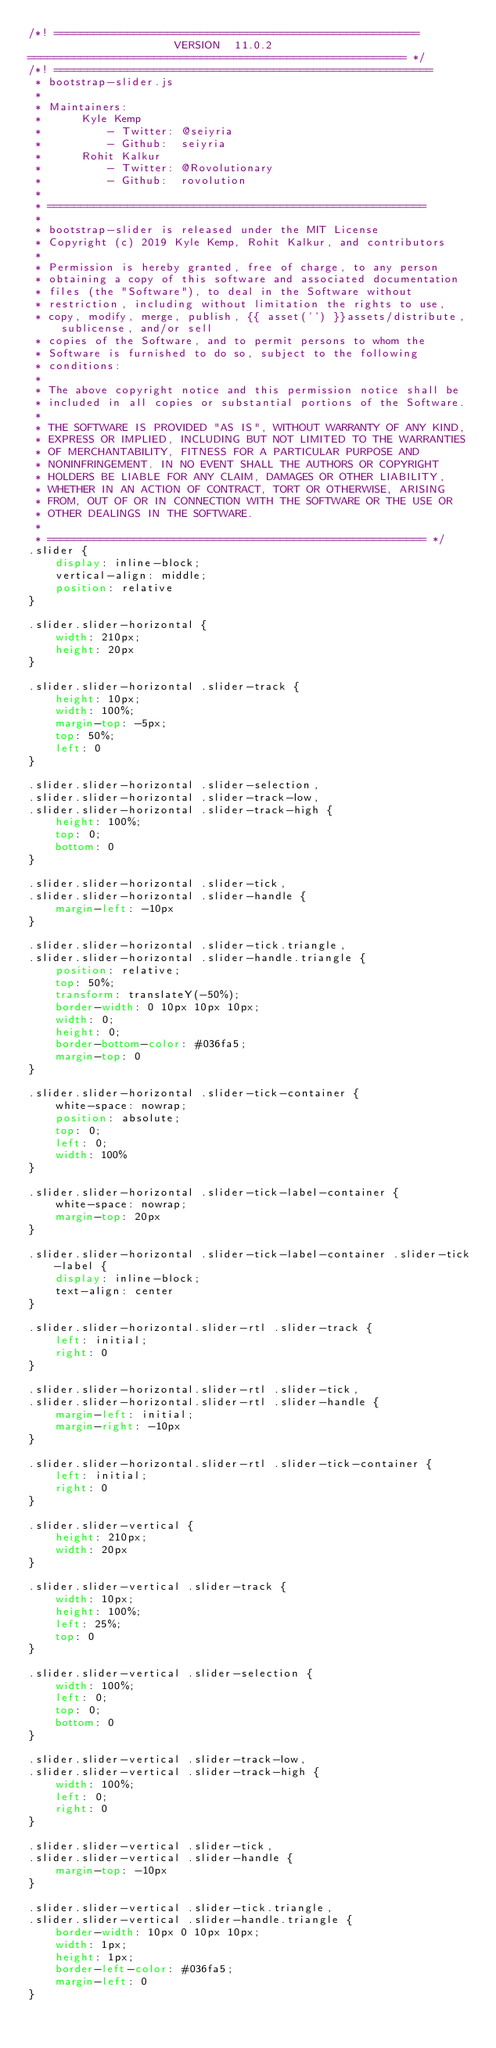<code> <loc_0><loc_0><loc_500><loc_500><_CSS_>/*! =======================================================
                      VERSION  11.0.2              
========================================================= */
/*! =========================================================
 * bootstrap-slider.js
 *
 * Maintainers:
 *		Kyle Kemp
 *			- Twitter: @seiyria
 *			- Github:  seiyria
 *		Rohit Kalkur
 *			- Twitter: @Rovolutionary
 *			- Github:  rovolution
 *
 * =========================================================
 *
 * bootstrap-slider is released under the MIT License
 * Copyright (c) 2019 Kyle Kemp, Rohit Kalkur, and contributors
 * 
 * Permission is hereby granted, free of charge, to any person
 * obtaining a copy of this software and associated documentation
 * files (the "Software"), to deal in the Software without
 * restriction, including without limitation the rights to use,
 * copy, modify, merge, publish, {{ asset('') }}assets/distribute, sublicense, and/or sell
 * copies of the Software, and to permit persons to whom the
 * Software is furnished to do so, subject to the following
 * conditions:
 * 
 * The above copyright notice and this permission notice shall be
 * included in all copies or substantial portions of the Software.
 * 
 * THE SOFTWARE IS PROVIDED "AS IS", WITHOUT WARRANTY OF ANY KIND,
 * EXPRESS OR IMPLIED, INCLUDING BUT NOT LIMITED TO THE WARRANTIES
 * OF MERCHANTABILITY, FITNESS FOR A PARTICULAR PURPOSE AND
 * NONINFRINGEMENT. IN NO EVENT SHALL THE AUTHORS OR COPYRIGHT
 * HOLDERS BE LIABLE FOR ANY CLAIM, DAMAGES OR OTHER LIABILITY,
 * WHETHER IN AN ACTION OF CONTRACT, TORT OR OTHERWISE, ARISING
 * FROM, OUT OF OR IN CONNECTION WITH THE SOFTWARE OR THE USE OR
 * OTHER DEALINGS IN THE SOFTWARE.
 *
 * ========================================================= */
.slider {
    display: inline-block;
    vertical-align: middle;
    position: relative
}

.slider.slider-horizontal {
    width: 210px;
    height: 20px
}

.slider.slider-horizontal .slider-track {
    height: 10px;
    width: 100%;
    margin-top: -5px;
    top: 50%;
    left: 0
}

.slider.slider-horizontal .slider-selection,
.slider.slider-horizontal .slider-track-low,
.slider.slider-horizontal .slider-track-high {
    height: 100%;
    top: 0;
    bottom: 0
}

.slider.slider-horizontal .slider-tick,
.slider.slider-horizontal .slider-handle {
    margin-left: -10px
}

.slider.slider-horizontal .slider-tick.triangle,
.slider.slider-horizontal .slider-handle.triangle {
    position: relative;
    top: 50%;
    transform: translateY(-50%);
    border-width: 0 10px 10px 10px;
    width: 0;
    height: 0;
    border-bottom-color: #036fa5;
    margin-top: 0
}

.slider.slider-horizontal .slider-tick-container {
    white-space: nowrap;
    position: absolute;
    top: 0;
    left: 0;
    width: 100%
}

.slider.slider-horizontal .slider-tick-label-container {
    white-space: nowrap;
    margin-top: 20px
}

.slider.slider-horizontal .slider-tick-label-container .slider-tick-label {
    display: inline-block;
    text-align: center
}

.slider.slider-horizontal.slider-rtl .slider-track {
    left: initial;
    right: 0
}

.slider.slider-horizontal.slider-rtl .slider-tick,
.slider.slider-horizontal.slider-rtl .slider-handle {
    margin-left: initial;
    margin-right: -10px
}

.slider.slider-horizontal.slider-rtl .slider-tick-container {
    left: initial;
    right: 0
}

.slider.slider-vertical {
    height: 210px;
    width: 20px
}

.slider.slider-vertical .slider-track {
    width: 10px;
    height: 100%;
    left: 25%;
    top: 0
}

.slider.slider-vertical .slider-selection {
    width: 100%;
    left: 0;
    top: 0;
    bottom: 0
}

.slider.slider-vertical .slider-track-low,
.slider.slider-vertical .slider-track-high {
    width: 100%;
    left: 0;
    right: 0
}

.slider.slider-vertical .slider-tick,
.slider.slider-vertical .slider-handle {
    margin-top: -10px
}

.slider.slider-vertical .slider-tick.triangle,
.slider.slider-vertical .slider-handle.triangle {
    border-width: 10px 0 10px 10px;
    width: 1px;
    height: 1px;
    border-left-color: #036fa5;
    margin-left: 0
}
</code> 